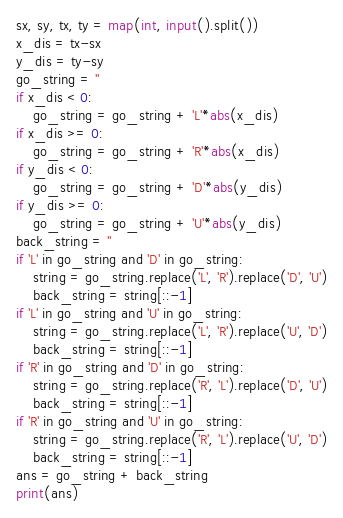<code> <loc_0><loc_0><loc_500><loc_500><_Python_>sx, sy, tx, ty = map(int, input().split())
x_dis = tx-sx
y_dis = ty-sy
go_string = ''
if x_dis < 0:
    go_string = go_string + 'L'*abs(x_dis)
if x_dis >= 0:
    go_string = go_string + 'R'*abs(x_dis)
if y_dis < 0:
    go_string = go_string + 'D'*abs(y_dis)
if y_dis >= 0:
    go_string = go_string + 'U'*abs(y_dis)
back_string = ''
if 'L' in go_string and 'D' in go_string:
    string = go_string.replace('L', 'R').replace('D', 'U')
    back_string = string[::-1]
if 'L' in go_string and 'U' in go_string:
    string = go_string.replace('L', 'R').replace('U', 'D')
    back_string = string[::-1]
if 'R' in go_string and 'D' in go_string:
    string = go_string.replace('R', 'L').replace('D', 'U')
    back_string = string[::-1]
if 'R' in go_string and 'U' in go_string:
    string = go_string.replace('R', 'L').replace('U', 'D')
    back_string = string[::-1]
ans = go_string + back_string
print(ans)
</code> 